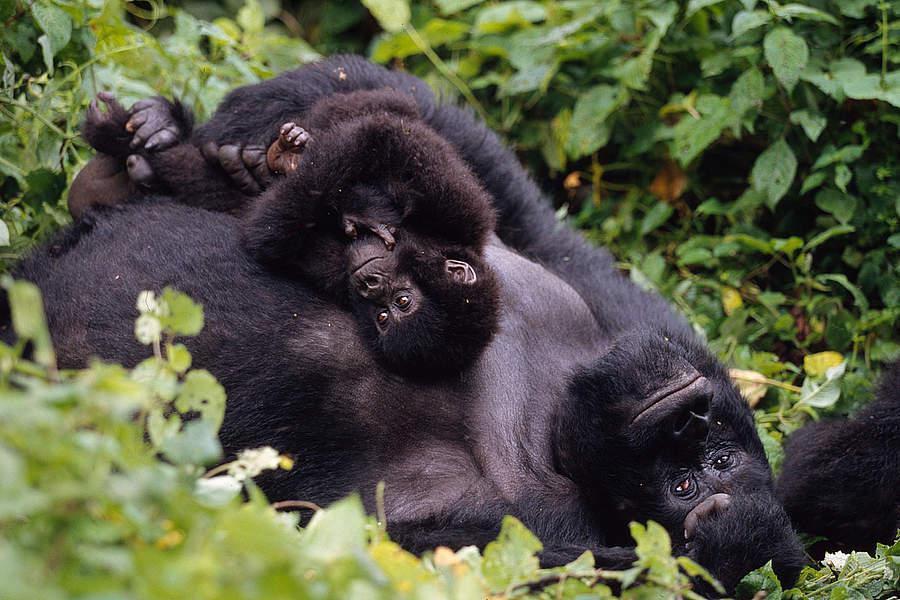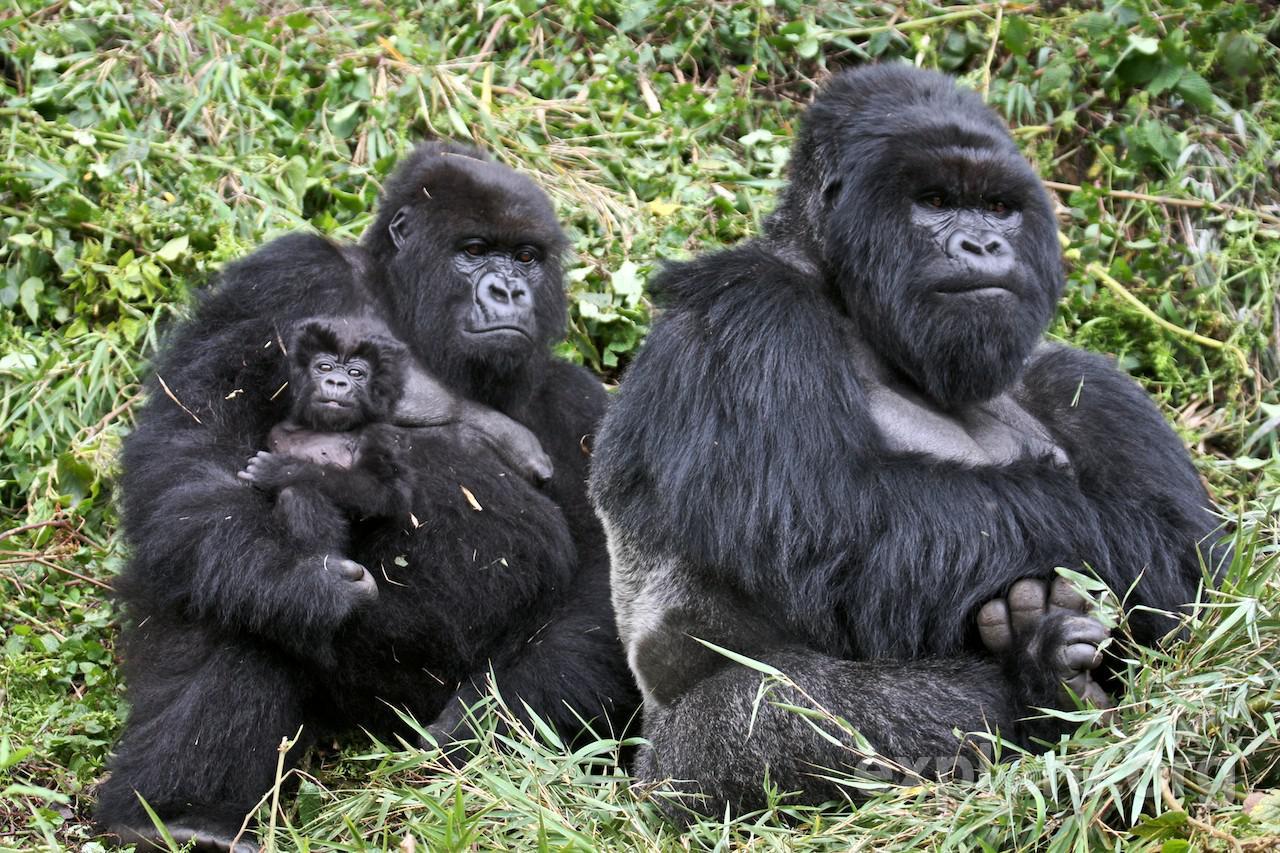The first image is the image on the left, the second image is the image on the right. Assess this claim about the two images: "One of the images features an adult gorilla carrying a baby gorilla.". Correct or not? Answer yes or no. Yes. The first image is the image on the left, the second image is the image on the right. Given the left and right images, does the statement "One of the images contain only one gorrilla." hold true? Answer yes or no. No. 